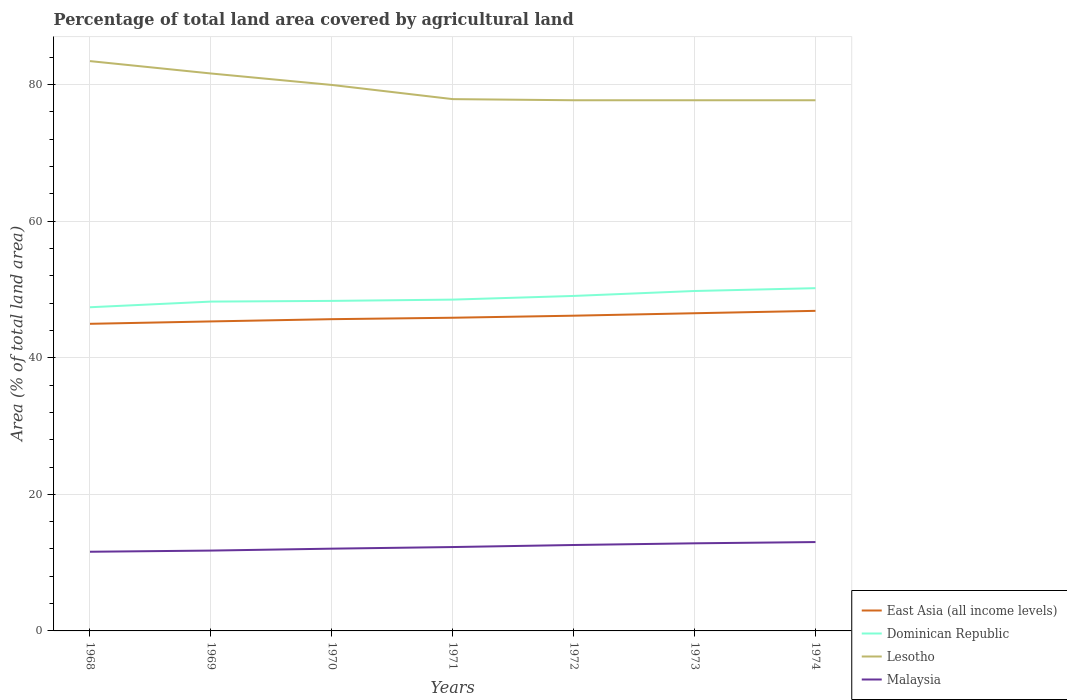Is the number of lines equal to the number of legend labels?
Provide a succinct answer. Yes. Across all years, what is the maximum percentage of agricultural land in East Asia (all income levels)?
Your answer should be very brief. 44.97. In which year was the percentage of agricultural land in Dominican Republic maximum?
Offer a terse response. 1968. What is the total percentage of agricultural land in Lesotho in the graph?
Offer a very short reply. 0.16. What is the difference between the highest and the second highest percentage of agricultural land in East Asia (all income levels)?
Provide a succinct answer. 1.9. What is the difference between two consecutive major ticks on the Y-axis?
Your answer should be compact. 20. Does the graph contain grids?
Provide a succinct answer. Yes. Where does the legend appear in the graph?
Offer a very short reply. Bottom right. What is the title of the graph?
Your response must be concise. Percentage of total land area covered by agricultural land. What is the label or title of the Y-axis?
Keep it short and to the point. Area (% of total land area). What is the Area (% of total land area) in East Asia (all income levels) in 1968?
Your response must be concise. 44.97. What is the Area (% of total land area) in Dominican Republic in 1968?
Ensure brevity in your answer.  47.39. What is the Area (% of total land area) in Lesotho in 1968?
Offer a very short reply. 83.43. What is the Area (% of total land area) in Malaysia in 1968?
Your answer should be very brief. 11.59. What is the Area (% of total land area) of East Asia (all income levels) in 1969?
Keep it short and to the point. 45.32. What is the Area (% of total land area) of Dominican Republic in 1969?
Offer a very short reply. 48.22. What is the Area (% of total land area) of Lesotho in 1969?
Give a very brief answer. 81.62. What is the Area (% of total land area) in Malaysia in 1969?
Keep it short and to the point. 11.76. What is the Area (% of total land area) of East Asia (all income levels) in 1970?
Provide a succinct answer. 45.65. What is the Area (% of total land area) of Dominican Republic in 1970?
Ensure brevity in your answer.  48.32. What is the Area (% of total land area) in Lesotho in 1970?
Keep it short and to the point. 79.94. What is the Area (% of total land area) in Malaysia in 1970?
Provide a short and direct response. 12.05. What is the Area (% of total land area) of East Asia (all income levels) in 1971?
Your response must be concise. 45.86. What is the Area (% of total land area) in Dominican Republic in 1971?
Keep it short and to the point. 48.51. What is the Area (% of total land area) of Lesotho in 1971?
Provide a succinct answer. 77.87. What is the Area (% of total land area) of Malaysia in 1971?
Your response must be concise. 12.28. What is the Area (% of total land area) of East Asia (all income levels) in 1972?
Your answer should be compact. 46.16. What is the Area (% of total land area) in Dominican Republic in 1972?
Ensure brevity in your answer.  49.05. What is the Area (% of total land area) in Lesotho in 1972?
Keep it short and to the point. 77.7. What is the Area (% of total land area) of Malaysia in 1972?
Your response must be concise. 12.58. What is the Area (% of total land area) of East Asia (all income levels) in 1973?
Your response must be concise. 46.52. What is the Area (% of total land area) in Dominican Republic in 1973?
Your response must be concise. 49.77. What is the Area (% of total land area) of Lesotho in 1973?
Your answer should be compact. 77.7. What is the Area (% of total land area) of Malaysia in 1973?
Keep it short and to the point. 12.83. What is the Area (% of total land area) of East Asia (all income levels) in 1974?
Give a very brief answer. 46.87. What is the Area (% of total land area) of Dominican Republic in 1974?
Make the answer very short. 50.19. What is the Area (% of total land area) of Lesotho in 1974?
Give a very brief answer. 77.7. What is the Area (% of total land area) of Malaysia in 1974?
Give a very brief answer. 13.01. Across all years, what is the maximum Area (% of total land area) in East Asia (all income levels)?
Ensure brevity in your answer.  46.87. Across all years, what is the maximum Area (% of total land area) of Dominican Republic?
Provide a succinct answer. 50.19. Across all years, what is the maximum Area (% of total land area) in Lesotho?
Provide a short and direct response. 83.43. Across all years, what is the maximum Area (% of total land area) in Malaysia?
Ensure brevity in your answer.  13.01. Across all years, what is the minimum Area (% of total land area) in East Asia (all income levels)?
Make the answer very short. 44.97. Across all years, what is the minimum Area (% of total land area) in Dominican Republic?
Your answer should be compact. 47.39. Across all years, what is the minimum Area (% of total land area) in Lesotho?
Keep it short and to the point. 77.7. Across all years, what is the minimum Area (% of total land area) of Malaysia?
Your answer should be very brief. 11.59. What is the total Area (% of total land area) of East Asia (all income levels) in the graph?
Offer a very short reply. 321.33. What is the total Area (% of total land area) of Dominican Republic in the graph?
Your answer should be compact. 341.45. What is the total Area (% of total land area) in Lesotho in the graph?
Provide a short and direct response. 555.96. What is the total Area (% of total land area) of Malaysia in the graph?
Offer a terse response. 86.1. What is the difference between the Area (% of total land area) of East Asia (all income levels) in 1968 and that in 1969?
Keep it short and to the point. -0.35. What is the difference between the Area (% of total land area) in Dominican Republic in 1968 and that in 1969?
Make the answer very short. -0.83. What is the difference between the Area (% of total land area) in Lesotho in 1968 and that in 1969?
Your answer should be very brief. 1.81. What is the difference between the Area (% of total land area) of Malaysia in 1968 and that in 1969?
Your answer should be very brief. -0.17. What is the difference between the Area (% of total land area) in East Asia (all income levels) in 1968 and that in 1970?
Your answer should be compact. -0.68. What is the difference between the Area (% of total land area) in Dominican Republic in 1968 and that in 1970?
Your response must be concise. -0.93. What is the difference between the Area (% of total land area) in Lesotho in 1968 and that in 1970?
Your response must be concise. 3.49. What is the difference between the Area (% of total land area) in Malaysia in 1968 and that in 1970?
Make the answer very short. -0.45. What is the difference between the Area (% of total land area) of East Asia (all income levels) in 1968 and that in 1971?
Keep it short and to the point. -0.89. What is the difference between the Area (% of total land area) in Dominican Republic in 1968 and that in 1971?
Make the answer very short. -1.12. What is the difference between the Area (% of total land area) of Lesotho in 1968 and that in 1971?
Your answer should be very brief. 5.57. What is the difference between the Area (% of total land area) of Malaysia in 1968 and that in 1971?
Your answer should be compact. -0.69. What is the difference between the Area (% of total land area) in East Asia (all income levels) in 1968 and that in 1972?
Keep it short and to the point. -1.19. What is the difference between the Area (% of total land area) in Dominican Republic in 1968 and that in 1972?
Ensure brevity in your answer.  -1.66. What is the difference between the Area (% of total land area) of Lesotho in 1968 and that in 1972?
Your response must be concise. 5.73. What is the difference between the Area (% of total land area) in Malaysia in 1968 and that in 1972?
Provide a succinct answer. -0.99. What is the difference between the Area (% of total land area) in East Asia (all income levels) in 1968 and that in 1973?
Offer a very short reply. -1.55. What is the difference between the Area (% of total land area) in Dominican Republic in 1968 and that in 1973?
Ensure brevity in your answer.  -2.38. What is the difference between the Area (% of total land area) in Lesotho in 1968 and that in 1973?
Your response must be concise. 5.73. What is the difference between the Area (% of total land area) of Malaysia in 1968 and that in 1973?
Give a very brief answer. -1.24. What is the difference between the Area (% of total land area) of East Asia (all income levels) in 1968 and that in 1974?
Provide a succinct answer. -1.9. What is the difference between the Area (% of total land area) of Dominican Republic in 1968 and that in 1974?
Your response must be concise. -2.79. What is the difference between the Area (% of total land area) in Lesotho in 1968 and that in 1974?
Provide a succinct answer. 5.73. What is the difference between the Area (% of total land area) of Malaysia in 1968 and that in 1974?
Provide a short and direct response. -1.42. What is the difference between the Area (% of total land area) of East Asia (all income levels) in 1969 and that in 1970?
Make the answer very short. -0.33. What is the difference between the Area (% of total land area) in Dominican Republic in 1969 and that in 1970?
Make the answer very short. -0.1. What is the difference between the Area (% of total land area) in Lesotho in 1969 and that in 1970?
Provide a succinct answer. 1.68. What is the difference between the Area (% of total land area) of Malaysia in 1969 and that in 1970?
Offer a very short reply. -0.28. What is the difference between the Area (% of total land area) of East Asia (all income levels) in 1969 and that in 1971?
Provide a succinct answer. -0.54. What is the difference between the Area (% of total land area) of Dominican Republic in 1969 and that in 1971?
Give a very brief answer. -0.29. What is the difference between the Area (% of total land area) in Lesotho in 1969 and that in 1971?
Make the answer very short. 3.75. What is the difference between the Area (% of total land area) of Malaysia in 1969 and that in 1971?
Provide a short and direct response. -0.52. What is the difference between the Area (% of total land area) in East Asia (all income levels) in 1969 and that in 1972?
Offer a terse response. -0.84. What is the difference between the Area (% of total land area) in Dominican Republic in 1969 and that in 1972?
Ensure brevity in your answer.  -0.83. What is the difference between the Area (% of total land area) of Lesotho in 1969 and that in 1972?
Give a very brief answer. 3.92. What is the difference between the Area (% of total land area) in Malaysia in 1969 and that in 1972?
Keep it short and to the point. -0.82. What is the difference between the Area (% of total land area) in East Asia (all income levels) in 1969 and that in 1973?
Offer a terse response. -1.2. What is the difference between the Area (% of total land area) of Dominican Republic in 1969 and that in 1973?
Your response must be concise. -1.55. What is the difference between the Area (% of total land area) of Lesotho in 1969 and that in 1973?
Keep it short and to the point. 3.92. What is the difference between the Area (% of total land area) in Malaysia in 1969 and that in 1973?
Offer a terse response. -1.06. What is the difference between the Area (% of total land area) in East Asia (all income levels) in 1969 and that in 1974?
Your answer should be compact. -1.55. What is the difference between the Area (% of total land area) in Dominican Republic in 1969 and that in 1974?
Your response must be concise. -1.97. What is the difference between the Area (% of total land area) of Lesotho in 1969 and that in 1974?
Provide a succinct answer. 3.92. What is the difference between the Area (% of total land area) in Malaysia in 1969 and that in 1974?
Your answer should be very brief. -1.25. What is the difference between the Area (% of total land area) of East Asia (all income levels) in 1970 and that in 1971?
Keep it short and to the point. -0.21. What is the difference between the Area (% of total land area) of Dominican Republic in 1970 and that in 1971?
Offer a terse response. -0.19. What is the difference between the Area (% of total land area) of Lesotho in 1970 and that in 1971?
Keep it short and to the point. 2.08. What is the difference between the Area (% of total land area) in Malaysia in 1970 and that in 1971?
Your answer should be very brief. -0.24. What is the difference between the Area (% of total land area) of East Asia (all income levels) in 1970 and that in 1972?
Provide a succinct answer. -0.51. What is the difference between the Area (% of total land area) of Dominican Republic in 1970 and that in 1972?
Ensure brevity in your answer.  -0.72. What is the difference between the Area (% of total land area) of Lesotho in 1970 and that in 1972?
Give a very brief answer. 2.24. What is the difference between the Area (% of total land area) in Malaysia in 1970 and that in 1972?
Your answer should be compact. -0.54. What is the difference between the Area (% of total land area) of East Asia (all income levels) in 1970 and that in 1973?
Offer a very short reply. -0.87. What is the difference between the Area (% of total land area) in Dominican Republic in 1970 and that in 1973?
Provide a succinct answer. -1.45. What is the difference between the Area (% of total land area) in Lesotho in 1970 and that in 1973?
Offer a terse response. 2.24. What is the difference between the Area (% of total land area) in Malaysia in 1970 and that in 1973?
Your answer should be compact. -0.78. What is the difference between the Area (% of total land area) of East Asia (all income levels) in 1970 and that in 1974?
Make the answer very short. -1.22. What is the difference between the Area (% of total land area) of Dominican Republic in 1970 and that in 1974?
Ensure brevity in your answer.  -1.86. What is the difference between the Area (% of total land area) of Lesotho in 1970 and that in 1974?
Provide a succinct answer. 2.24. What is the difference between the Area (% of total land area) in Malaysia in 1970 and that in 1974?
Offer a terse response. -0.97. What is the difference between the Area (% of total land area) of East Asia (all income levels) in 1971 and that in 1972?
Ensure brevity in your answer.  -0.3. What is the difference between the Area (% of total land area) of Dominican Republic in 1971 and that in 1972?
Make the answer very short. -0.54. What is the difference between the Area (% of total land area) of Lesotho in 1971 and that in 1972?
Give a very brief answer. 0.16. What is the difference between the Area (% of total land area) in Malaysia in 1971 and that in 1972?
Ensure brevity in your answer.  -0.3. What is the difference between the Area (% of total land area) in East Asia (all income levels) in 1971 and that in 1973?
Offer a very short reply. -0.66. What is the difference between the Area (% of total land area) of Dominican Republic in 1971 and that in 1973?
Your answer should be compact. -1.26. What is the difference between the Area (% of total land area) of Lesotho in 1971 and that in 1973?
Ensure brevity in your answer.  0.16. What is the difference between the Area (% of total land area) in Malaysia in 1971 and that in 1973?
Give a very brief answer. -0.55. What is the difference between the Area (% of total land area) in East Asia (all income levels) in 1971 and that in 1974?
Your answer should be very brief. -1.01. What is the difference between the Area (% of total land area) of Dominican Republic in 1971 and that in 1974?
Keep it short and to the point. -1.68. What is the difference between the Area (% of total land area) in Lesotho in 1971 and that in 1974?
Your response must be concise. 0.16. What is the difference between the Area (% of total land area) of Malaysia in 1971 and that in 1974?
Make the answer very short. -0.73. What is the difference between the Area (% of total land area) in East Asia (all income levels) in 1972 and that in 1973?
Your answer should be very brief. -0.36. What is the difference between the Area (% of total land area) of Dominican Republic in 1972 and that in 1973?
Offer a terse response. -0.72. What is the difference between the Area (% of total land area) in Lesotho in 1972 and that in 1973?
Offer a terse response. 0. What is the difference between the Area (% of total land area) of Malaysia in 1972 and that in 1973?
Your response must be concise. -0.25. What is the difference between the Area (% of total land area) in East Asia (all income levels) in 1972 and that in 1974?
Offer a very short reply. -0.71. What is the difference between the Area (% of total land area) in Dominican Republic in 1972 and that in 1974?
Ensure brevity in your answer.  -1.14. What is the difference between the Area (% of total land area) in Lesotho in 1972 and that in 1974?
Ensure brevity in your answer.  0. What is the difference between the Area (% of total land area) in Malaysia in 1972 and that in 1974?
Give a very brief answer. -0.43. What is the difference between the Area (% of total land area) of East Asia (all income levels) in 1973 and that in 1974?
Provide a succinct answer. -0.35. What is the difference between the Area (% of total land area) in Dominican Republic in 1973 and that in 1974?
Your response must be concise. -0.41. What is the difference between the Area (% of total land area) of Malaysia in 1973 and that in 1974?
Make the answer very short. -0.18. What is the difference between the Area (% of total land area) in East Asia (all income levels) in 1968 and the Area (% of total land area) in Dominican Republic in 1969?
Offer a terse response. -3.25. What is the difference between the Area (% of total land area) in East Asia (all income levels) in 1968 and the Area (% of total land area) in Lesotho in 1969?
Provide a short and direct response. -36.65. What is the difference between the Area (% of total land area) of East Asia (all income levels) in 1968 and the Area (% of total land area) of Malaysia in 1969?
Offer a very short reply. 33.2. What is the difference between the Area (% of total land area) of Dominican Republic in 1968 and the Area (% of total land area) of Lesotho in 1969?
Your response must be concise. -34.23. What is the difference between the Area (% of total land area) of Dominican Republic in 1968 and the Area (% of total land area) of Malaysia in 1969?
Provide a short and direct response. 35.63. What is the difference between the Area (% of total land area) of Lesotho in 1968 and the Area (% of total land area) of Malaysia in 1969?
Keep it short and to the point. 71.67. What is the difference between the Area (% of total land area) of East Asia (all income levels) in 1968 and the Area (% of total land area) of Dominican Republic in 1970?
Ensure brevity in your answer.  -3.36. What is the difference between the Area (% of total land area) in East Asia (all income levels) in 1968 and the Area (% of total land area) in Lesotho in 1970?
Give a very brief answer. -34.97. What is the difference between the Area (% of total land area) in East Asia (all income levels) in 1968 and the Area (% of total land area) in Malaysia in 1970?
Your answer should be very brief. 32.92. What is the difference between the Area (% of total land area) of Dominican Republic in 1968 and the Area (% of total land area) of Lesotho in 1970?
Provide a succinct answer. -32.55. What is the difference between the Area (% of total land area) in Dominican Republic in 1968 and the Area (% of total land area) in Malaysia in 1970?
Give a very brief answer. 35.35. What is the difference between the Area (% of total land area) in Lesotho in 1968 and the Area (% of total land area) in Malaysia in 1970?
Provide a short and direct response. 71.39. What is the difference between the Area (% of total land area) of East Asia (all income levels) in 1968 and the Area (% of total land area) of Dominican Republic in 1971?
Provide a short and direct response. -3.54. What is the difference between the Area (% of total land area) of East Asia (all income levels) in 1968 and the Area (% of total land area) of Lesotho in 1971?
Ensure brevity in your answer.  -32.9. What is the difference between the Area (% of total land area) in East Asia (all income levels) in 1968 and the Area (% of total land area) in Malaysia in 1971?
Your response must be concise. 32.69. What is the difference between the Area (% of total land area) of Dominican Republic in 1968 and the Area (% of total land area) of Lesotho in 1971?
Your response must be concise. -30.47. What is the difference between the Area (% of total land area) of Dominican Republic in 1968 and the Area (% of total land area) of Malaysia in 1971?
Give a very brief answer. 35.11. What is the difference between the Area (% of total land area) in Lesotho in 1968 and the Area (% of total land area) in Malaysia in 1971?
Keep it short and to the point. 71.15. What is the difference between the Area (% of total land area) of East Asia (all income levels) in 1968 and the Area (% of total land area) of Dominican Republic in 1972?
Make the answer very short. -4.08. What is the difference between the Area (% of total land area) in East Asia (all income levels) in 1968 and the Area (% of total land area) in Lesotho in 1972?
Your answer should be compact. -32.73. What is the difference between the Area (% of total land area) of East Asia (all income levels) in 1968 and the Area (% of total land area) of Malaysia in 1972?
Keep it short and to the point. 32.39. What is the difference between the Area (% of total land area) in Dominican Republic in 1968 and the Area (% of total land area) in Lesotho in 1972?
Provide a succinct answer. -30.31. What is the difference between the Area (% of total land area) in Dominican Republic in 1968 and the Area (% of total land area) in Malaysia in 1972?
Give a very brief answer. 34.81. What is the difference between the Area (% of total land area) of Lesotho in 1968 and the Area (% of total land area) of Malaysia in 1972?
Offer a very short reply. 70.85. What is the difference between the Area (% of total land area) of East Asia (all income levels) in 1968 and the Area (% of total land area) of Dominican Republic in 1973?
Make the answer very short. -4.81. What is the difference between the Area (% of total land area) in East Asia (all income levels) in 1968 and the Area (% of total land area) in Lesotho in 1973?
Offer a very short reply. -32.73. What is the difference between the Area (% of total land area) in East Asia (all income levels) in 1968 and the Area (% of total land area) in Malaysia in 1973?
Ensure brevity in your answer.  32.14. What is the difference between the Area (% of total land area) of Dominican Republic in 1968 and the Area (% of total land area) of Lesotho in 1973?
Give a very brief answer. -30.31. What is the difference between the Area (% of total land area) of Dominican Republic in 1968 and the Area (% of total land area) of Malaysia in 1973?
Your answer should be very brief. 34.56. What is the difference between the Area (% of total land area) of Lesotho in 1968 and the Area (% of total land area) of Malaysia in 1973?
Provide a succinct answer. 70.6. What is the difference between the Area (% of total land area) in East Asia (all income levels) in 1968 and the Area (% of total land area) in Dominican Republic in 1974?
Your answer should be compact. -5.22. What is the difference between the Area (% of total land area) in East Asia (all income levels) in 1968 and the Area (% of total land area) in Lesotho in 1974?
Give a very brief answer. -32.73. What is the difference between the Area (% of total land area) in East Asia (all income levels) in 1968 and the Area (% of total land area) in Malaysia in 1974?
Provide a short and direct response. 31.96. What is the difference between the Area (% of total land area) of Dominican Republic in 1968 and the Area (% of total land area) of Lesotho in 1974?
Ensure brevity in your answer.  -30.31. What is the difference between the Area (% of total land area) of Dominican Republic in 1968 and the Area (% of total land area) of Malaysia in 1974?
Make the answer very short. 34.38. What is the difference between the Area (% of total land area) of Lesotho in 1968 and the Area (% of total land area) of Malaysia in 1974?
Offer a very short reply. 70.42. What is the difference between the Area (% of total land area) in East Asia (all income levels) in 1969 and the Area (% of total land area) in Dominican Republic in 1970?
Give a very brief answer. -3.01. What is the difference between the Area (% of total land area) of East Asia (all income levels) in 1969 and the Area (% of total land area) of Lesotho in 1970?
Offer a terse response. -34.62. What is the difference between the Area (% of total land area) in East Asia (all income levels) in 1969 and the Area (% of total land area) in Malaysia in 1970?
Your answer should be very brief. 33.27. What is the difference between the Area (% of total land area) in Dominican Republic in 1969 and the Area (% of total land area) in Lesotho in 1970?
Offer a terse response. -31.72. What is the difference between the Area (% of total land area) in Dominican Republic in 1969 and the Area (% of total land area) in Malaysia in 1970?
Keep it short and to the point. 36.18. What is the difference between the Area (% of total land area) in Lesotho in 1969 and the Area (% of total land area) in Malaysia in 1970?
Offer a terse response. 69.58. What is the difference between the Area (% of total land area) in East Asia (all income levels) in 1969 and the Area (% of total land area) in Dominican Republic in 1971?
Your answer should be very brief. -3.19. What is the difference between the Area (% of total land area) in East Asia (all income levels) in 1969 and the Area (% of total land area) in Lesotho in 1971?
Make the answer very short. -32.55. What is the difference between the Area (% of total land area) of East Asia (all income levels) in 1969 and the Area (% of total land area) of Malaysia in 1971?
Ensure brevity in your answer.  33.04. What is the difference between the Area (% of total land area) in Dominican Republic in 1969 and the Area (% of total land area) in Lesotho in 1971?
Provide a succinct answer. -29.65. What is the difference between the Area (% of total land area) in Dominican Republic in 1969 and the Area (% of total land area) in Malaysia in 1971?
Provide a short and direct response. 35.94. What is the difference between the Area (% of total land area) in Lesotho in 1969 and the Area (% of total land area) in Malaysia in 1971?
Ensure brevity in your answer.  69.34. What is the difference between the Area (% of total land area) of East Asia (all income levels) in 1969 and the Area (% of total land area) of Dominican Republic in 1972?
Provide a succinct answer. -3.73. What is the difference between the Area (% of total land area) in East Asia (all income levels) in 1969 and the Area (% of total land area) in Lesotho in 1972?
Your answer should be compact. -32.38. What is the difference between the Area (% of total land area) in East Asia (all income levels) in 1969 and the Area (% of total land area) in Malaysia in 1972?
Your response must be concise. 32.74. What is the difference between the Area (% of total land area) in Dominican Republic in 1969 and the Area (% of total land area) in Lesotho in 1972?
Offer a very short reply. -29.48. What is the difference between the Area (% of total land area) of Dominican Republic in 1969 and the Area (% of total land area) of Malaysia in 1972?
Ensure brevity in your answer.  35.64. What is the difference between the Area (% of total land area) of Lesotho in 1969 and the Area (% of total land area) of Malaysia in 1972?
Offer a terse response. 69.04. What is the difference between the Area (% of total land area) of East Asia (all income levels) in 1969 and the Area (% of total land area) of Dominican Republic in 1973?
Your answer should be very brief. -4.45. What is the difference between the Area (% of total land area) in East Asia (all income levels) in 1969 and the Area (% of total land area) in Lesotho in 1973?
Give a very brief answer. -32.38. What is the difference between the Area (% of total land area) in East Asia (all income levels) in 1969 and the Area (% of total land area) in Malaysia in 1973?
Offer a very short reply. 32.49. What is the difference between the Area (% of total land area) of Dominican Republic in 1969 and the Area (% of total land area) of Lesotho in 1973?
Offer a very short reply. -29.48. What is the difference between the Area (% of total land area) in Dominican Republic in 1969 and the Area (% of total land area) in Malaysia in 1973?
Your answer should be compact. 35.39. What is the difference between the Area (% of total land area) in Lesotho in 1969 and the Area (% of total land area) in Malaysia in 1973?
Provide a succinct answer. 68.79. What is the difference between the Area (% of total land area) of East Asia (all income levels) in 1969 and the Area (% of total land area) of Dominican Republic in 1974?
Make the answer very short. -4.87. What is the difference between the Area (% of total land area) of East Asia (all income levels) in 1969 and the Area (% of total land area) of Lesotho in 1974?
Offer a very short reply. -32.38. What is the difference between the Area (% of total land area) in East Asia (all income levels) in 1969 and the Area (% of total land area) in Malaysia in 1974?
Ensure brevity in your answer.  32.31. What is the difference between the Area (% of total land area) in Dominican Republic in 1969 and the Area (% of total land area) in Lesotho in 1974?
Ensure brevity in your answer.  -29.48. What is the difference between the Area (% of total land area) of Dominican Republic in 1969 and the Area (% of total land area) of Malaysia in 1974?
Your answer should be compact. 35.21. What is the difference between the Area (% of total land area) of Lesotho in 1969 and the Area (% of total land area) of Malaysia in 1974?
Offer a terse response. 68.61. What is the difference between the Area (% of total land area) in East Asia (all income levels) in 1970 and the Area (% of total land area) in Dominican Republic in 1971?
Offer a terse response. -2.86. What is the difference between the Area (% of total land area) in East Asia (all income levels) in 1970 and the Area (% of total land area) in Lesotho in 1971?
Provide a succinct answer. -32.22. What is the difference between the Area (% of total land area) in East Asia (all income levels) in 1970 and the Area (% of total land area) in Malaysia in 1971?
Your response must be concise. 33.37. What is the difference between the Area (% of total land area) of Dominican Republic in 1970 and the Area (% of total land area) of Lesotho in 1971?
Keep it short and to the point. -29.54. What is the difference between the Area (% of total land area) in Dominican Republic in 1970 and the Area (% of total land area) in Malaysia in 1971?
Your answer should be very brief. 36.04. What is the difference between the Area (% of total land area) of Lesotho in 1970 and the Area (% of total land area) of Malaysia in 1971?
Your response must be concise. 67.66. What is the difference between the Area (% of total land area) of East Asia (all income levels) in 1970 and the Area (% of total land area) of Dominican Republic in 1972?
Provide a succinct answer. -3.4. What is the difference between the Area (% of total land area) of East Asia (all income levels) in 1970 and the Area (% of total land area) of Lesotho in 1972?
Your response must be concise. -32.05. What is the difference between the Area (% of total land area) of East Asia (all income levels) in 1970 and the Area (% of total land area) of Malaysia in 1972?
Keep it short and to the point. 33.07. What is the difference between the Area (% of total land area) in Dominican Republic in 1970 and the Area (% of total land area) in Lesotho in 1972?
Your answer should be very brief. -29.38. What is the difference between the Area (% of total land area) in Dominican Republic in 1970 and the Area (% of total land area) in Malaysia in 1972?
Your response must be concise. 35.74. What is the difference between the Area (% of total land area) in Lesotho in 1970 and the Area (% of total land area) in Malaysia in 1972?
Your answer should be very brief. 67.36. What is the difference between the Area (% of total land area) of East Asia (all income levels) in 1970 and the Area (% of total land area) of Dominican Republic in 1973?
Offer a terse response. -4.13. What is the difference between the Area (% of total land area) of East Asia (all income levels) in 1970 and the Area (% of total land area) of Lesotho in 1973?
Your response must be concise. -32.05. What is the difference between the Area (% of total land area) in East Asia (all income levels) in 1970 and the Area (% of total land area) in Malaysia in 1973?
Offer a very short reply. 32.82. What is the difference between the Area (% of total land area) of Dominican Republic in 1970 and the Area (% of total land area) of Lesotho in 1973?
Your response must be concise. -29.38. What is the difference between the Area (% of total land area) of Dominican Republic in 1970 and the Area (% of total land area) of Malaysia in 1973?
Your answer should be very brief. 35.5. What is the difference between the Area (% of total land area) in Lesotho in 1970 and the Area (% of total land area) in Malaysia in 1973?
Offer a terse response. 67.11. What is the difference between the Area (% of total land area) of East Asia (all income levels) in 1970 and the Area (% of total land area) of Dominican Republic in 1974?
Your response must be concise. -4.54. What is the difference between the Area (% of total land area) of East Asia (all income levels) in 1970 and the Area (% of total land area) of Lesotho in 1974?
Your answer should be compact. -32.05. What is the difference between the Area (% of total land area) in East Asia (all income levels) in 1970 and the Area (% of total land area) in Malaysia in 1974?
Make the answer very short. 32.64. What is the difference between the Area (% of total land area) of Dominican Republic in 1970 and the Area (% of total land area) of Lesotho in 1974?
Ensure brevity in your answer.  -29.38. What is the difference between the Area (% of total land area) in Dominican Republic in 1970 and the Area (% of total land area) in Malaysia in 1974?
Provide a succinct answer. 35.31. What is the difference between the Area (% of total land area) in Lesotho in 1970 and the Area (% of total land area) in Malaysia in 1974?
Your answer should be compact. 66.93. What is the difference between the Area (% of total land area) in East Asia (all income levels) in 1971 and the Area (% of total land area) in Dominican Republic in 1972?
Offer a terse response. -3.19. What is the difference between the Area (% of total land area) of East Asia (all income levels) in 1971 and the Area (% of total land area) of Lesotho in 1972?
Make the answer very short. -31.84. What is the difference between the Area (% of total land area) in East Asia (all income levels) in 1971 and the Area (% of total land area) in Malaysia in 1972?
Offer a very short reply. 33.28. What is the difference between the Area (% of total land area) in Dominican Republic in 1971 and the Area (% of total land area) in Lesotho in 1972?
Provide a succinct answer. -29.19. What is the difference between the Area (% of total land area) of Dominican Republic in 1971 and the Area (% of total land area) of Malaysia in 1972?
Your answer should be very brief. 35.93. What is the difference between the Area (% of total land area) in Lesotho in 1971 and the Area (% of total land area) in Malaysia in 1972?
Provide a short and direct response. 65.29. What is the difference between the Area (% of total land area) in East Asia (all income levels) in 1971 and the Area (% of total land area) in Dominican Republic in 1973?
Provide a succinct answer. -3.92. What is the difference between the Area (% of total land area) of East Asia (all income levels) in 1971 and the Area (% of total land area) of Lesotho in 1973?
Your response must be concise. -31.84. What is the difference between the Area (% of total land area) in East Asia (all income levels) in 1971 and the Area (% of total land area) in Malaysia in 1973?
Provide a succinct answer. 33.03. What is the difference between the Area (% of total land area) in Dominican Republic in 1971 and the Area (% of total land area) in Lesotho in 1973?
Keep it short and to the point. -29.19. What is the difference between the Area (% of total land area) of Dominican Republic in 1971 and the Area (% of total land area) of Malaysia in 1973?
Keep it short and to the point. 35.68. What is the difference between the Area (% of total land area) of Lesotho in 1971 and the Area (% of total land area) of Malaysia in 1973?
Provide a succinct answer. 65.04. What is the difference between the Area (% of total land area) in East Asia (all income levels) in 1971 and the Area (% of total land area) in Dominican Republic in 1974?
Your answer should be compact. -4.33. What is the difference between the Area (% of total land area) in East Asia (all income levels) in 1971 and the Area (% of total land area) in Lesotho in 1974?
Provide a short and direct response. -31.84. What is the difference between the Area (% of total land area) of East Asia (all income levels) in 1971 and the Area (% of total land area) of Malaysia in 1974?
Give a very brief answer. 32.85. What is the difference between the Area (% of total land area) of Dominican Republic in 1971 and the Area (% of total land area) of Lesotho in 1974?
Provide a short and direct response. -29.19. What is the difference between the Area (% of total land area) of Dominican Republic in 1971 and the Area (% of total land area) of Malaysia in 1974?
Ensure brevity in your answer.  35.5. What is the difference between the Area (% of total land area) of Lesotho in 1971 and the Area (% of total land area) of Malaysia in 1974?
Offer a terse response. 64.86. What is the difference between the Area (% of total land area) in East Asia (all income levels) in 1972 and the Area (% of total land area) in Dominican Republic in 1973?
Your response must be concise. -3.62. What is the difference between the Area (% of total land area) of East Asia (all income levels) in 1972 and the Area (% of total land area) of Lesotho in 1973?
Give a very brief answer. -31.55. What is the difference between the Area (% of total land area) of East Asia (all income levels) in 1972 and the Area (% of total land area) of Malaysia in 1973?
Ensure brevity in your answer.  33.33. What is the difference between the Area (% of total land area) of Dominican Republic in 1972 and the Area (% of total land area) of Lesotho in 1973?
Your answer should be very brief. -28.65. What is the difference between the Area (% of total land area) of Dominican Republic in 1972 and the Area (% of total land area) of Malaysia in 1973?
Keep it short and to the point. 36.22. What is the difference between the Area (% of total land area) in Lesotho in 1972 and the Area (% of total land area) in Malaysia in 1973?
Provide a succinct answer. 64.87. What is the difference between the Area (% of total land area) in East Asia (all income levels) in 1972 and the Area (% of total land area) in Dominican Republic in 1974?
Provide a succinct answer. -4.03. What is the difference between the Area (% of total land area) in East Asia (all income levels) in 1972 and the Area (% of total land area) in Lesotho in 1974?
Your response must be concise. -31.55. What is the difference between the Area (% of total land area) in East Asia (all income levels) in 1972 and the Area (% of total land area) in Malaysia in 1974?
Make the answer very short. 33.15. What is the difference between the Area (% of total land area) in Dominican Republic in 1972 and the Area (% of total land area) in Lesotho in 1974?
Your response must be concise. -28.65. What is the difference between the Area (% of total land area) in Dominican Republic in 1972 and the Area (% of total land area) in Malaysia in 1974?
Offer a very short reply. 36.04. What is the difference between the Area (% of total land area) in Lesotho in 1972 and the Area (% of total land area) in Malaysia in 1974?
Give a very brief answer. 64.69. What is the difference between the Area (% of total land area) in East Asia (all income levels) in 1973 and the Area (% of total land area) in Dominican Republic in 1974?
Ensure brevity in your answer.  -3.67. What is the difference between the Area (% of total land area) in East Asia (all income levels) in 1973 and the Area (% of total land area) in Lesotho in 1974?
Provide a short and direct response. -31.19. What is the difference between the Area (% of total land area) of East Asia (all income levels) in 1973 and the Area (% of total land area) of Malaysia in 1974?
Offer a terse response. 33.51. What is the difference between the Area (% of total land area) in Dominican Republic in 1973 and the Area (% of total land area) in Lesotho in 1974?
Keep it short and to the point. -27.93. What is the difference between the Area (% of total land area) in Dominican Republic in 1973 and the Area (% of total land area) in Malaysia in 1974?
Offer a terse response. 36.76. What is the difference between the Area (% of total land area) of Lesotho in 1973 and the Area (% of total land area) of Malaysia in 1974?
Keep it short and to the point. 64.69. What is the average Area (% of total land area) in East Asia (all income levels) per year?
Offer a very short reply. 45.9. What is the average Area (% of total land area) in Dominican Republic per year?
Offer a terse response. 48.78. What is the average Area (% of total land area) in Lesotho per year?
Keep it short and to the point. 79.42. What is the average Area (% of total land area) in Malaysia per year?
Provide a succinct answer. 12.3. In the year 1968, what is the difference between the Area (% of total land area) of East Asia (all income levels) and Area (% of total land area) of Dominican Republic?
Give a very brief answer. -2.43. In the year 1968, what is the difference between the Area (% of total land area) of East Asia (all income levels) and Area (% of total land area) of Lesotho?
Your response must be concise. -38.47. In the year 1968, what is the difference between the Area (% of total land area) in East Asia (all income levels) and Area (% of total land area) in Malaysia?
Your answer should be very brief. 33.38. In the year 1968, what is the difference between the Area (% of total land area) in Dominican Republic and Area (% of total land area) in Lesotho?
Ensure brevity in your answer.  -36.04. In the year 1968, what is the difference between the Area (% of total land area) of Dominican Republic and Area (% of total land area) of Malaysia?
Your response must be concise. 35.8. In the year 1968, what is the difference between the Area (% of total land area) of Lesotho and Area (% of total land area) of Malaysia?
Your answer should be compact. 71.84. In the year 1969, what is the difference between the Area (% of total land area) of East Asia (all income levels) and Area (% of total land area) of Dominican Republic?
Your answer should be compact. -2.9. In the year 1969, what is the difference between the Area (% of total land area) of East Asia (all income levels) and Area (% of total land area) of Lesotho?
Your answer should be compact. -36.3. In the year 1969, what is the difference between the Area (% of total land area) of East Asia (all income levels) and Area (% of total land area) of Malaysia?
Your response must be concise. 33.55. In the year 1969, what is the difference between the Area (% of total land area) of Dominican Republic and Area (% of total land area) of Lesotho?
Your response must be concise. -33.4. In the year 1969, what is the difference between the Area (% of total land area) in Dominican Republic and Area (% of total land area) in Malaysia?
Offer a very short reply. 36.46. In the year 1969, what is the difference between the Area (% of total land area) in Lesotho and Area (% of total land area) in Malaysia?
Keep it short and to the point. 69.86. In the year 1970, what is the difference between the Area (% of total land area) in East Asia (all income levels) and Area (% of total land area) in Dominican Republic?
Give a very brief answer. -2.68. In the year 1970, what is the difference between the Area (% of total land area) in East Asia (all income levels) and Area (% of total land area) in Lesotho?
Keep it short and to the point. -34.29. In the year 1970, what is the difference between the Area (% of total land area) of East Asia (all income levels) and Area (% of total land area) of Malaysia?
Your answer should be compact. 33.6. In the year 1970, what is the difference between the Area (% of total land area) in Dominican Republic and Area (% of total land area) in Lesotho?
Offer a terse response. -31.62. In the year 1970, what is the difference between the Area (% of total land area) of Dominican Republic and Area (% of total land area) of Malaysia?
Keep it short and to the point. 36.28. In the year 1970, what is the difference between the Area (% of total land area) in Lesotho and Area (% of total land area) in Malaysia?
Keep it short and to the point. 67.9. In the year 1971, what is the difference between the Area (% of total land area) of East Asia (all income levels) and Area (% of total land area) of Dominican Republic?
Your response must be concise. -2.65. In the year 1971, what is the difference between the Area (% of total land area) of East Asia (all income levels) and Area (% of total land area) of Lesotho?
Your answer should be compact. -32.01. In the year 1971, what is the difference between the Area (% of total land area) of East Asia (all income levels) and Area (% of total land area) of Malaysia?
Your answer should be very brief. 33.58. In the year 1971, what is the difference between the Area (% of total land area) of Dominican Republic and Area (% of total land area) of Lesotho?
Keep it short and to the point. -29.36. In the year 1971, what is the difference between the Area (% of total land area) of Dominican Republic and Area (% of total land area) of Malaysia?
Your answer should be compact. 36.23. In the year 1971, what is the difference between the Area (% of total land area) in Lesotho and Area (% of total land area) in Malaysia?
Your answer should be very brief. 65.59. In the year 1972, what is the difference between the Area (% of total land area) in East Asia (all income levels) and Area (% of total land area) in Dominican Republic?
Your answer should be very brief. -2.89. In the year 1972, what is the difference between the Area (% of total land area) of East Asia (all income levels) and Area (% of total land area) of Lesotho?
Make the answer very short. -31.55. In the year 1972, what is the difference between the Area (% of total land area) of East Asia (all income levels) and Area (% of total land area) of Malaysia?
Ensure brevity in your answer.  33.58. In the year 1972, what is the difference between the Area (% of total land area) of Dominican Republic and Area (% of total land area) of Lesotho?
Make the answer very short. -28.65. In the year 1972, what is the difference between the Area (% of total land area) of Dominican Republic and Area (% of total land area) of Malaysia?
Keep it short and to the point. 36.47. In the year 1972, what is the difference between the Area (% of total land area) of Lesotho and Area (% of total land area) of Malaysia?
Provide a succinct answer. 65.12. In the year 1973, what is the difference between the Area (% of total land area) of East Asia (all income levels) and Area (% of total land area) of Dominican Republic?
Offer a very short reply. -3.26. In the year 1973, what is the difference between the Area (% of total land area) of East Asia (all income levels) and Area (% of total land area) of Lesotho?
Ensure brevity in your answer.  -31.19. In the year 1973, what is the difference between the Area (% of total land area) in East Asia (all income levels) and Area (% of total land area) in Malaysia?
Your response must be concise. 33.69. In the year 1973, what is the difference between the Area (% of total land area) in Dominican Republic and Area (% of total land area) in Lesotho?
Your answer should be compact. -27.93. In the year 1973, what is the difference between the Area (% of total land area) in Dominican Republic and Area (% of total land area) in Malaysia?
Offer a very short reply. 36.94. In the year 1973, what is the difference between the Area (% of total land area) of Lesotho and Area (% of total land area) of Malaysia?
Your answer should be very brief. 64.87. In the year 1974, what is the difference between the Area (% of total land area) of East Asia (all income levels) and Area (% of total land area) of Dominican Republic?
Give a very brief answer. -3.32. In the year 1974, what is the difference between the Area (% of total land area) of East Asia (all income levels) and Area (% of total land area) of Lesotho?
Offer a very short reply. -30.84. In the year 1974, what is the difference between the Area (% of total land area) of East Asia (all income levels) and Area (% of total land area) of Malaysia?
Keep it short and to the point. 33.86. In the year 1974, what is the difference between the Area (% of total land area) in Dominican Republic and Area (% of total land area) in Lesotho?
Your answer should be very brief. -27.51. In the year 1974, what is the difference between the Area (% of total land area) in Dominican Republic and Area (% of total land area) in Malaysia?
Ensure brevity in your answer.  37.18. In the year 1974, what is the difference between the Area (% of total land area) of Lesotho and Area (% of total land area) of Malaysia?
Provide a succinct answer. 64.69. What is the ratio of the Area (% of total land area) of Dominican Republic in 1968 to that in 1969?
Offer a terse response. 0.98. What is the ratio of the Area (% of total land area) in Lesotho in 1968 to that in 1969?
Give a very brief answer. 1.02. What is the ratio of the Area (% of total land area) of Malaysia in 1968 to that in 1969?
Provide a short and direct response. 0.99. What is the ratio of the Area (% of total land area) of East Asia (all income levels) in 1968 to that in 1970?
Ensure brevity in your answer.  0.99. What is the ratio of the Area (% of total land area) in Dominican Republic in 1968 to that in 1970?
Give a very brief answer. 0.98. What is the ratio of the Area (% of total land area) in Lesotho in 1968 to that in 1970?
Keep it short and to the point. 1.04. What is the ratio of the Area (% of total land area) in Malaysia in 1968 to that in 1970?
Your response must be concise. 0.96. What is the ratio of the Area (% of total land area) of East Asia (all income levels) in 1968 to that in 1971?
Make the answer very short. 0.98. What is the ratio of the Area (% of total land area) of Lesotho in 1968 to that in 1971?
Keep it short and to the point. 1.07. What is the ratio of the Area (% of total land area) of Malaysia in 1968 to that in 1971?
Offer a terse response. 0.94. What is the ratio of the Area (% of total land area) in East Asia (all income levels) in 1968 to that in 1972?
Provide a succinct answer. 0.97. What is the ratio of the Area (% of total land area) in Dominican Republic in 1968 to that in 1972?
Provide a succinct answer. 0.97. What is the ratio of the Area (% of total land area) of Lesotho in 1968 to that in 1972?
Your answer should be compact. 1.07. What is the ratio of the Area (% of total land area) in Malaysia in 1968 to that in 1972?
Give a very brief answer. 0.92. What is the ratio of the Area (% of total land area) in East Asia (all income levels) in 1968 to that in 1973?
Make the answer very short. 0.97. What is the ratio of the Area (% of total land area) in Dominican Republic in 1968 to that in 1973?
Offer a very short reply. 0.95. What is the ratio of the Area (% of total land area) of Lesotho in 1968 to that in 1973?
Ensure brevity in your answer.  1.07. What is the ratio of the Area (% of total land area) in Malaysia in 1968 to that in 1973?
Your response must be concise. 0.9. What is the ratio of the Area (% of total land area) of East Asia (all income levels) in 1968 to that in 1974?
Make the answer very short. 0.96. What is the ratio of the Area (% of total land area) of Dominican Republic in 1968 to that in 1974?
Give a very brief answer. 0.94. What is the ratio of the Area (% of total land area) of Lesotho in 1968 to that in 1974?
Your response must be concise. 1.07. What is the ratio of the Area (% of total land area) in Malaysia in 1968 to that in 1974?
Ensure brevity in your answer.  0.89. What is the ratio of the Area (% of total land area) in Dominican Republic in 1969 to that in 1970?
Provide a succinct answer. 1. What is the ratio of the Area (% of total land area) in Lesotho in 1969 to that in 1970?
Ensure brevity in your answer.  1.02. What is the ratio of the Area (% of total land area) in Malaysia in 1969 to that in 1970?
Offer a very short reply. 0.98. What is the ratio of the Area (% of total land area) of Dominican Republic in 1969 to that in 1971?
Your answer should be compact. 0.99. What is the ratio of the Area (% of total land area) in Lesotho in 1969 to that in 1971?
Your answer should be very brief. 1.05. What is the ratio of the Area (% of total land area) of Malaysia in 1969 to that in 1971?
Your response must be concise. 0.96. What is the ratio of the Area (% of total land area) of East Asia (all income levels) in 1969 to that in 1972?
Make the answer very short. 0.98. What is the ratio of the Area (% of total land area) of Dominican Republic in 1969 to that in 1972?
Give a very brief answer. 0.98. What is the ratio of the Area (% of total land area) in Lesotho in 1969 to that in 1972?
Your response must be concise. 1.05. What is the ratio of the Area (% of total land area) of Malaysia in 1969 to that in 1972?
Ensure brevity in your answer.  0.94. What is the ratio of the Area (% of total land area) in East Asia (all income levels) in 1969 to that in 1973?
Keep it short and to the point. 0.97. What is the ratio of the Area (% of total land area) in Dominican Republic in 1969 to that in 1973?
Keep it short and to the point. 0.97. What is the ratio of the Area (% of total land area) of Lesotho in 1969 to that in 1973?
Provide a short and direct response. 1.05. What is the ratio of the Area (% of total land area) in Malaysia in 1969 to that in 1973?
Provide a short and direct response. 0.92. What is the ratio of the Area (% of total land area) of Dominican Republic in 1969 to that in 1974?
Your response must be concise. 0.96. What is the ratio of the Area (% of total land area) in Lesotho in 1969 to that in 1974?
Make the answer very short. 1.05. What is the ratio of the Area (% of total land area) in Malaysia in 1969 to that in 1974?
Give a very brief answer. 0.9. What is the ratio of the Area (% of total land area) in East Asia (all income levels) in 1970 to that in 1971?
Provide a succinct answer. 1. What is the ratio of the Area (% of total land area) of Lesotho in 1970 to that in 1971?
Your answer should be very brief. 1.03. What is the ratio of the Area (% of total land area) of Malaysia in 1970 to that in 1971?
Provide a short and direct response. 0.98. What is the ratio of the Area (% of total land area) of East Asia (all income levels) in 1970 to that in 1972?
Ensure brevity in your answer.  0.99. What is the ratio of the Area (% of total land area) of Dominican Republic in 1970 to that in 1972?
Your response must be concise. 0.99. What is the ratio of the Area (% of total land area) in Lesotho in 1970 to that in 1972?
Your answer should be very brief. 1.03. What is the ratio of the Area (% of total land area) in Malaysia in 1970 to that in 1972?
Make the answer very short. 0.96. What is the ratio of the Area (% of total land area) in East Asia (all income levels) in 1970 to that in 1973?
Ensure brevity in your answer.  0.98. What is the ratio of the Area (% of total land area) of Dominican Republic in 1970 to that in 1973?
Make the answer very short. 0.97. What is the ratio of the Area (% of total land area) of Lesotho in 1970 to that in 1973?
Offer a terse response. 1.03. What is the ratio of the Area (% of total land area) in Malaysia in 1970 to that in 1973?
Ensure brevity in your answer.  0.94. What is the ratio of the Area (% of total land area) of East Asia (all income levels) in 1970 to that in 1974?
Make the answer very short. 0.97. What is the ratio of the Area (% of total land area) in Dominican Republic in 1970 to that in 1974?
Provide a short and direct response. 0.96. What is the ratio of the Area (% of total land area) in Lesotho in 1970 to that in 1974?
Provide a succinct answer. 1.03. What is the ratio of the Area (% of total land area) in Malaysia in 1970 to that in 1974?
Provide a succinct answer. 0.93. What is the ratio of the Area (% of total land area) in Lesotho in 1971 to that in 1972?
Keep it short and to the point. 1. What is the ratio of the Area (% of total land area) in Malaysia in 1971 to that in 1972?
Your response must be concise. 0.98. What is the ratio of the Area (% of total land area) of East Asia (all income levels) in 1971 to that in 1973?
Your response must be concise. 0.99. What is the ratio of the Area (% of total land area) of Dominican Republic in 1971 to that in 1973?
Offer a terse response. 0.97. What is the ratio of the Area (% of total land area) in Lesotho in 1971 to that in 1973?
Keep it short and to the point. 1. What is the ratio of the Area (% of total land area) in Malaysia in 1971 to that in 1973?
Make the answer very short. 0.96. What is the ratio of the Area (% of total land area) in East Asia (all income levels) in 1971 to that in 1974?
Provide a short and direct response. 0.98. What is the ratio of the Area (% of total land area) in Dominican Republic in 1971 to that in 1974?
Provide a succinct answer. 0.97. What is the ratio of the Area (% of total land area) in Malaysia in 1971 to that in 1974?
Your answer should be compact. 0.94. What is the ratio of the Area (% of total land area) of East Asia (all income levels) in 1972 to that in 1973?
Your answer should be compact. 0.99. What is the ratio of the Area (% of total land area) of Dominican Republic in 1972 to that in 1973?
Your response must be concise. 0.99. What is the ratio of the Area (% of total land area) of Malaysia in 1972 to that in 1973?
Your answer should be very brief. 0.98. What is the ratio of the Area (% of total land area) in Dominican Republic in 1972 to that in 1974?
Offer a terse response. 0.98. What is the ratio of the Area (% of total land area) of Malaysia in 1972 to that in 1974?
Provide a short and direct response. 0.97. What is the ratio of the Area (% of total land area) of East Asia (all income levels) in 1973 to that in 1974?
Your answer should be compact. 0.99. What is the ratio of the Area (% of total land area) of Lesotho in 1973 to that in 1974?
Offer a terse response. 1. What is the difference between the highest and the second highest Area (% of total land area) of East Asia (all income levels)?
Keep it short and to the point. 0.35. What is the difference between the highest and the second highest Area (% of total land area) of Dominican Republic?
Provide a short and direct response. 0.41. What is the difference between the highest and the second highest Area (% of total land area) in Lesotho?
Your response must be concise. 1.81. What is the difference between the highest and the second highest Area (% of total land area) in Malaysia?
Offer a terse response. 0.18. What is the difference between the highest and the lowest Area (% of total land area) in East Asia (all income levels)?
Ensure brevity in your answer.  1.9. What is the difference between the highest and the lowest Area (% of total land area) in Dominican Republic?
Keep it short and to the point. 2.79. What is the difference between the highest and the lowest Area (% of total land area) of Lesotho?
Provide a succinct answer. 5.73. What is the difference between the highest and the lowest Area (% of total land area) of Malaysia?
Offer a very short reply. 1.42. 